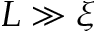Convert formula to latex. <formula><loc_0><loc_0><loc_500><loc_500>L \gg \xi</formula> 